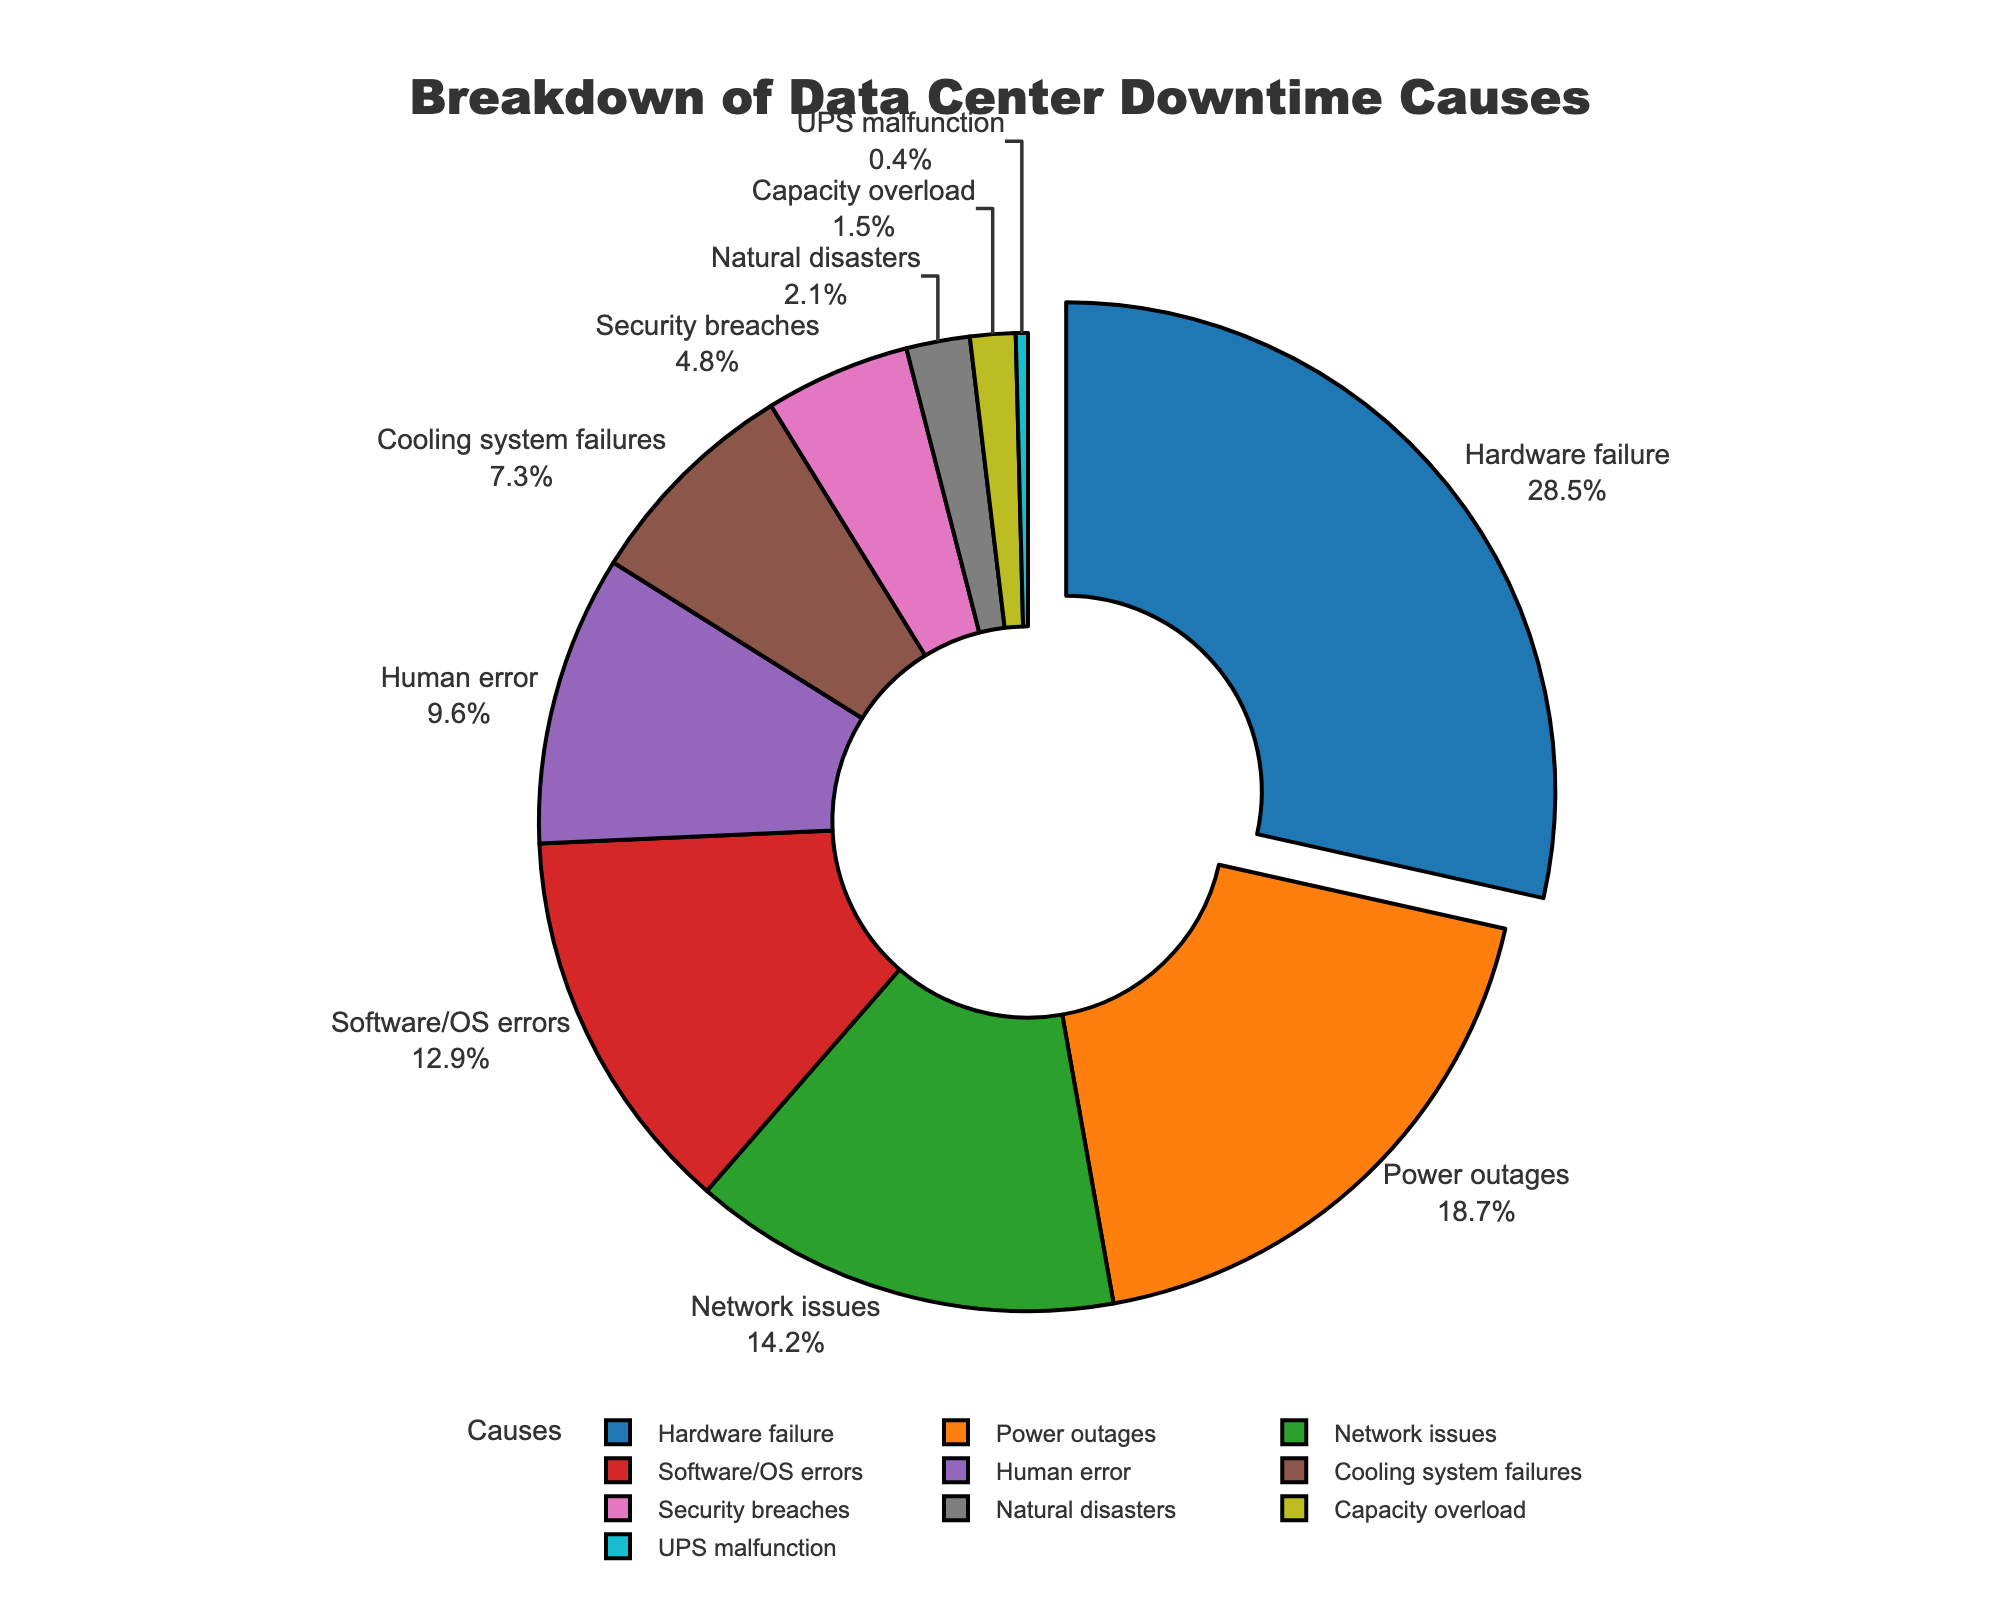Which cause is responsible for the highest percentage of data center downtime? By looking at the pie chart, we can observe that the segment pulled out from the rest represents the cause responsible for the highest percentage of downtime. The corresponding label reads "Hardware failure," with a percentage of 28.5%.
Answer: Hardware failure Which two causes, when combined, account for the highest percentage of data center downtime? To determine this, we need to identify the two largest segments on the pie chart and add their percentages. The largest is "Hardware failure" at 28.5%, and the next largest is "Power outages" at 18.7%. Summing these gives us 28.5% + 18.7% = 47.2%.
Answer: Hardware failure and Power outages How many causes account for less than 5% of data center downtime each? We can count the number of segments labeled with percentages less than 5% on the pie chart. These segments are "Security breaches" (4.8%), "Natural disasters" (2.1%), "Capacity overload" (1.5%), and "UPS malfunction" (0.4%). Thus, there are four such causes.
Answer: Four What is the combined percentage of data center downtime caused by software/OS errors and human error? To find this, sum the percentages for "Software/OS errors" (12.9%) and "Human error" (9.6%) from the chart. This gives us 12.9% + 9.6% = 22.5%.
Answer: 22.5% Which cause is represented by the smallest segment on the pie chart? By examining the smallest segment, we can see that it represents "UPS malfunction," with a percentage of 0.4%.
Answer: UPS malfunction Are power outages responsible for more downtime than network issues? We compare the percentages for "Power outages" (18.7%) and "Network issues" (14.2%) as observed on the pie chart. Since 18.7% is greater than 14.2%, power outages cause more downtime.
Answer: Yes Among human error and cooling system failures, which cause has a higher percentage of data center downtime? By comparing the two segments on the pie chart, we see that "Human error" accounts for 9.6%, while "Cooling system failures" account for 7.3%. Therefore, human error has a higher percentage.
Answer: Human error If we exclude the top three causes of data center downtime, what percentage does the remaining causes collectively account for? First, identify the top three causes: "Hardware failure" (28.5%), "Power outages" (18.7%), and "Network issues" (14.2%). Next, sum these percentages: 28.5% + 18.7% + 14.2% = 61.4%. Subtract this sum from 100% to find the remaining causes' collective percentage: 100% - 61.4% = 38.6%.
Answer: 38.6% Which segment appears to be the third largest, and what is its associated cause? The third largest segment on the pie chart is the one following "Hardware failure" and "Power outages." It represents "Network issues" with a percentage of 14.2%.
Answer: Network issues, 14.2% 